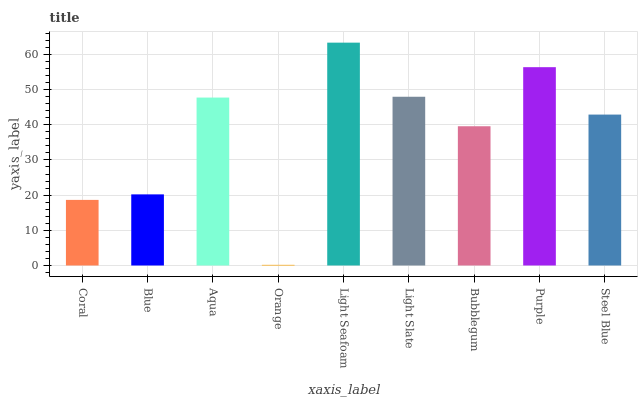Is Blue the minimum?
Answer yes or no. No. Is Blue the maximum?
Answer yes or no. No. Is Blue greater than Coral?
Answer yes or no. Yes. Is Coral less than Blue?
Answer yes or no. Yes. Is Coral greater than Blue?
Answer yes or no. No. Is Blue less than Coral?
Answer yes or no. No. Is Steel Blue the high median?
Answer yes or no. Yes. Is Steel Blue the low median?
Answer yes or no. Yes. Is Purple the high median?
Answer yes or no. No. Is Light Slate the low median?
Answer yes or no. No. 